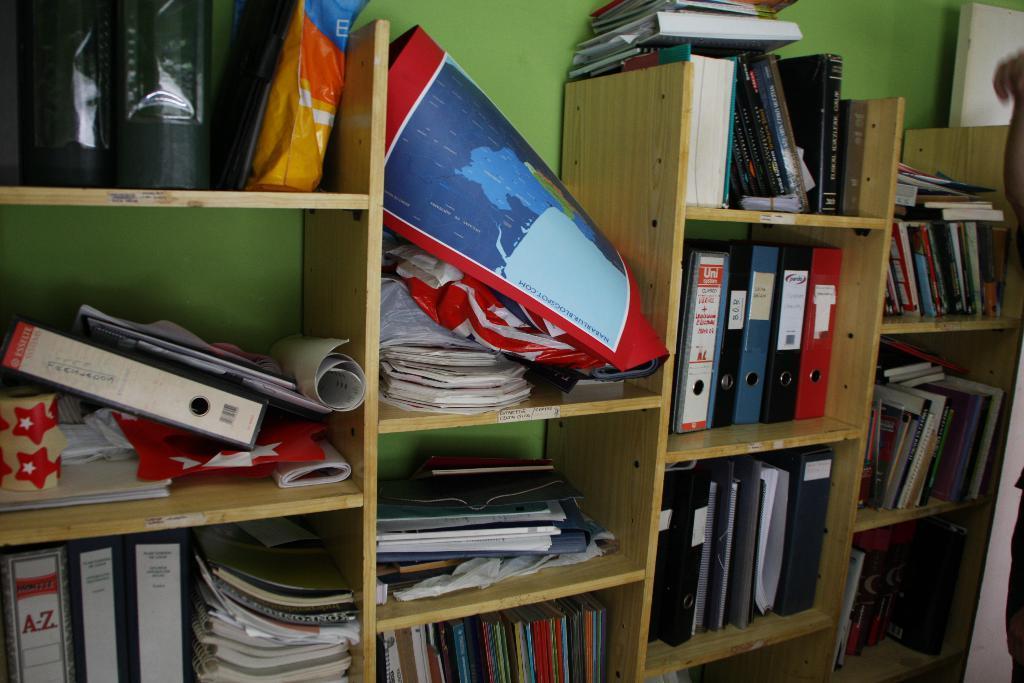How would you summarize this image in a sentence or two? In this image I can see few books and papers in the racks, background the wall is in green color. 